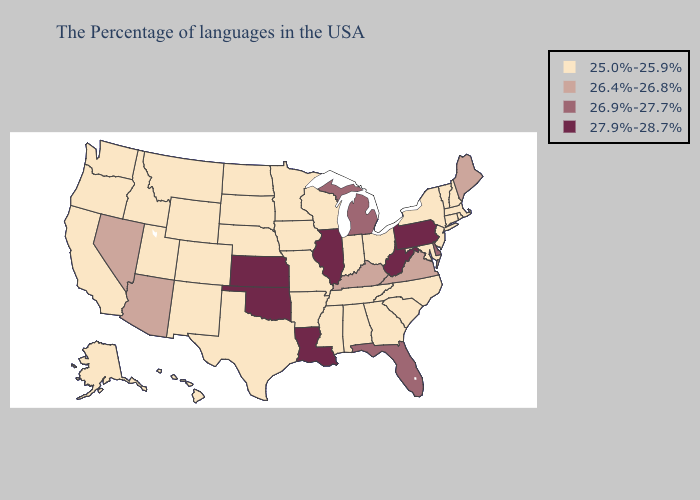Does the map have missing data?
Concise answer only. No. Does Kentucky have the lowest value in the USA?
Quick response, please. No. Does South Dakota have the same value as Kansas?
Write a very short answer. No. What is the lowest value in the USA?
Quick response, please. 25.0%-25.9%. Does Connecticut have the lowest value in the USA?
Quick response, please. Yes. Does Oklahoma have a lower value than Illinois?
Give a very brief answer. No. What is the value of Alaska?
Quick response, please. 25.0%-25.9%. Name the states that have a value in the range 25.0%-25.9%?
Give a very brief answer. Massachusetts, Rhode Island, New Hampshire, Vermont, Connecticut, New York, New Jersey, Maryland, North Carolina, South Carolina, Ohio, Georgia, Indiana, Alabama, Tennessee, Wisconsin, Mississippi, Missouri, Arkansas, Minnesota, Iowa, Nebraska, Texas, South Dakota, North Dakota, Wyoming, Colorado, New Mexico, Utah, Montana, Idaho, California, Washington, Oregon, Alaska, Hawaii. Does Kansas have the highest value in the MidWest?
Short answer required. Yes. How many symbols are there in the legend?
Be succinct. 4. Does Oregon have the lowest value in the USA?
Quick response, please. Yes. What is the value of North Dakota?
Concise answer only. 25.0%-25.9%. What is the value of Rhode Island?
Be succinct. 25.0%-25.9%. Among the states that border Rhode Island , which have the lowest value?
Be succinct. Massachusetts, Connecticut. 